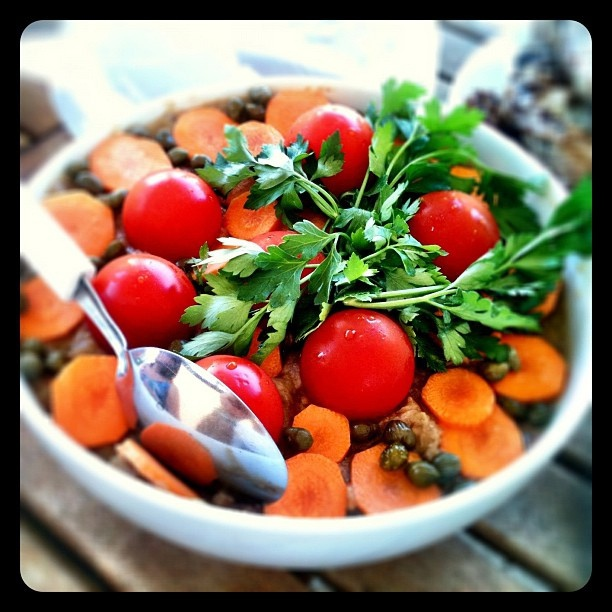Describe the objects in this image and their specific colors. I can see dining table in ivory, black, gray, and red tones, bowl in black, ivory, and red tones, spoon in black, white, darkgray, and brown tones, carrot in black, red, and orange tones, and carrot in black, red, orange, and maroon tones in this image. 